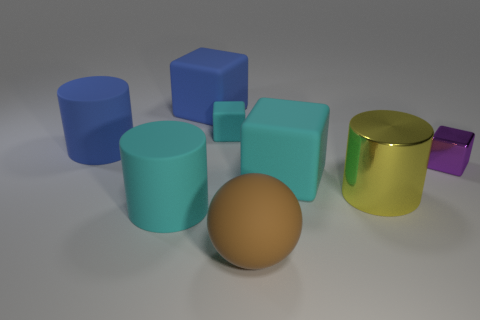Add 1 small rubber balls. How many objects exist? 9 Subtract all cylinders. How many objects are left? 5 Add 3 small things. How many small things are left? 5 Add 6 tiny shiny cylinders. How many tiny shiny cylinders exist? 6 Subtract 0 red cylinders. How many objects are left? 8 Subtract all brown objects. Subtract all large shiny cylinders. How many objects are left? 6 